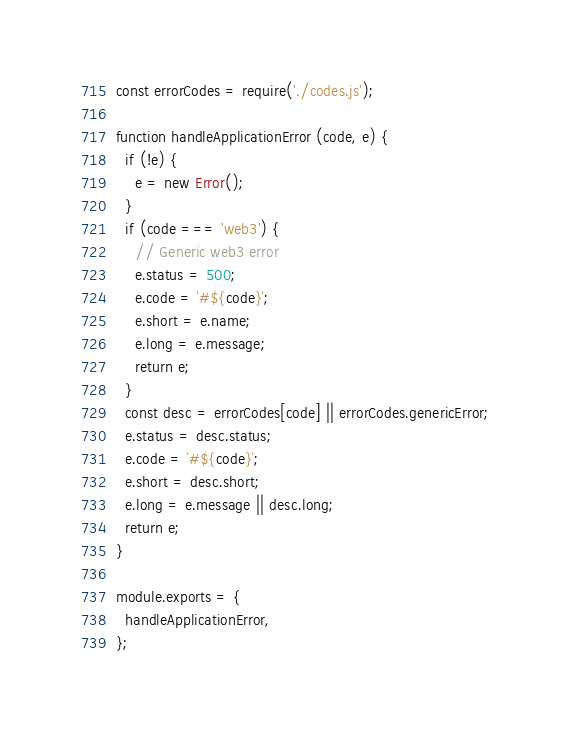Convert code to text. <code><loc_0><loc_0><loc_500><loc_500><_JavaScript_>const errorCodes = require('./codes.js');

function handleApplicationError (code, e) {
  if (!e) {
    e = new Error();
  }
  if (code === 'web3') {
    // Generic web3 error
    e.status = 500;
    e.code = `#${code}`;
    e.short = e.name;
    e.long = e.message;
    return e;
  }
  const desc = errorCodes[code] || errorCodes.genericError;
  e.status = desc.status;
  e.code = `#${code}`;
  e.short = desc.short;
  e.long = e.message || desc.long;
  return e;
}

module.exports = {
  handleApplicationError,
};
</code> 